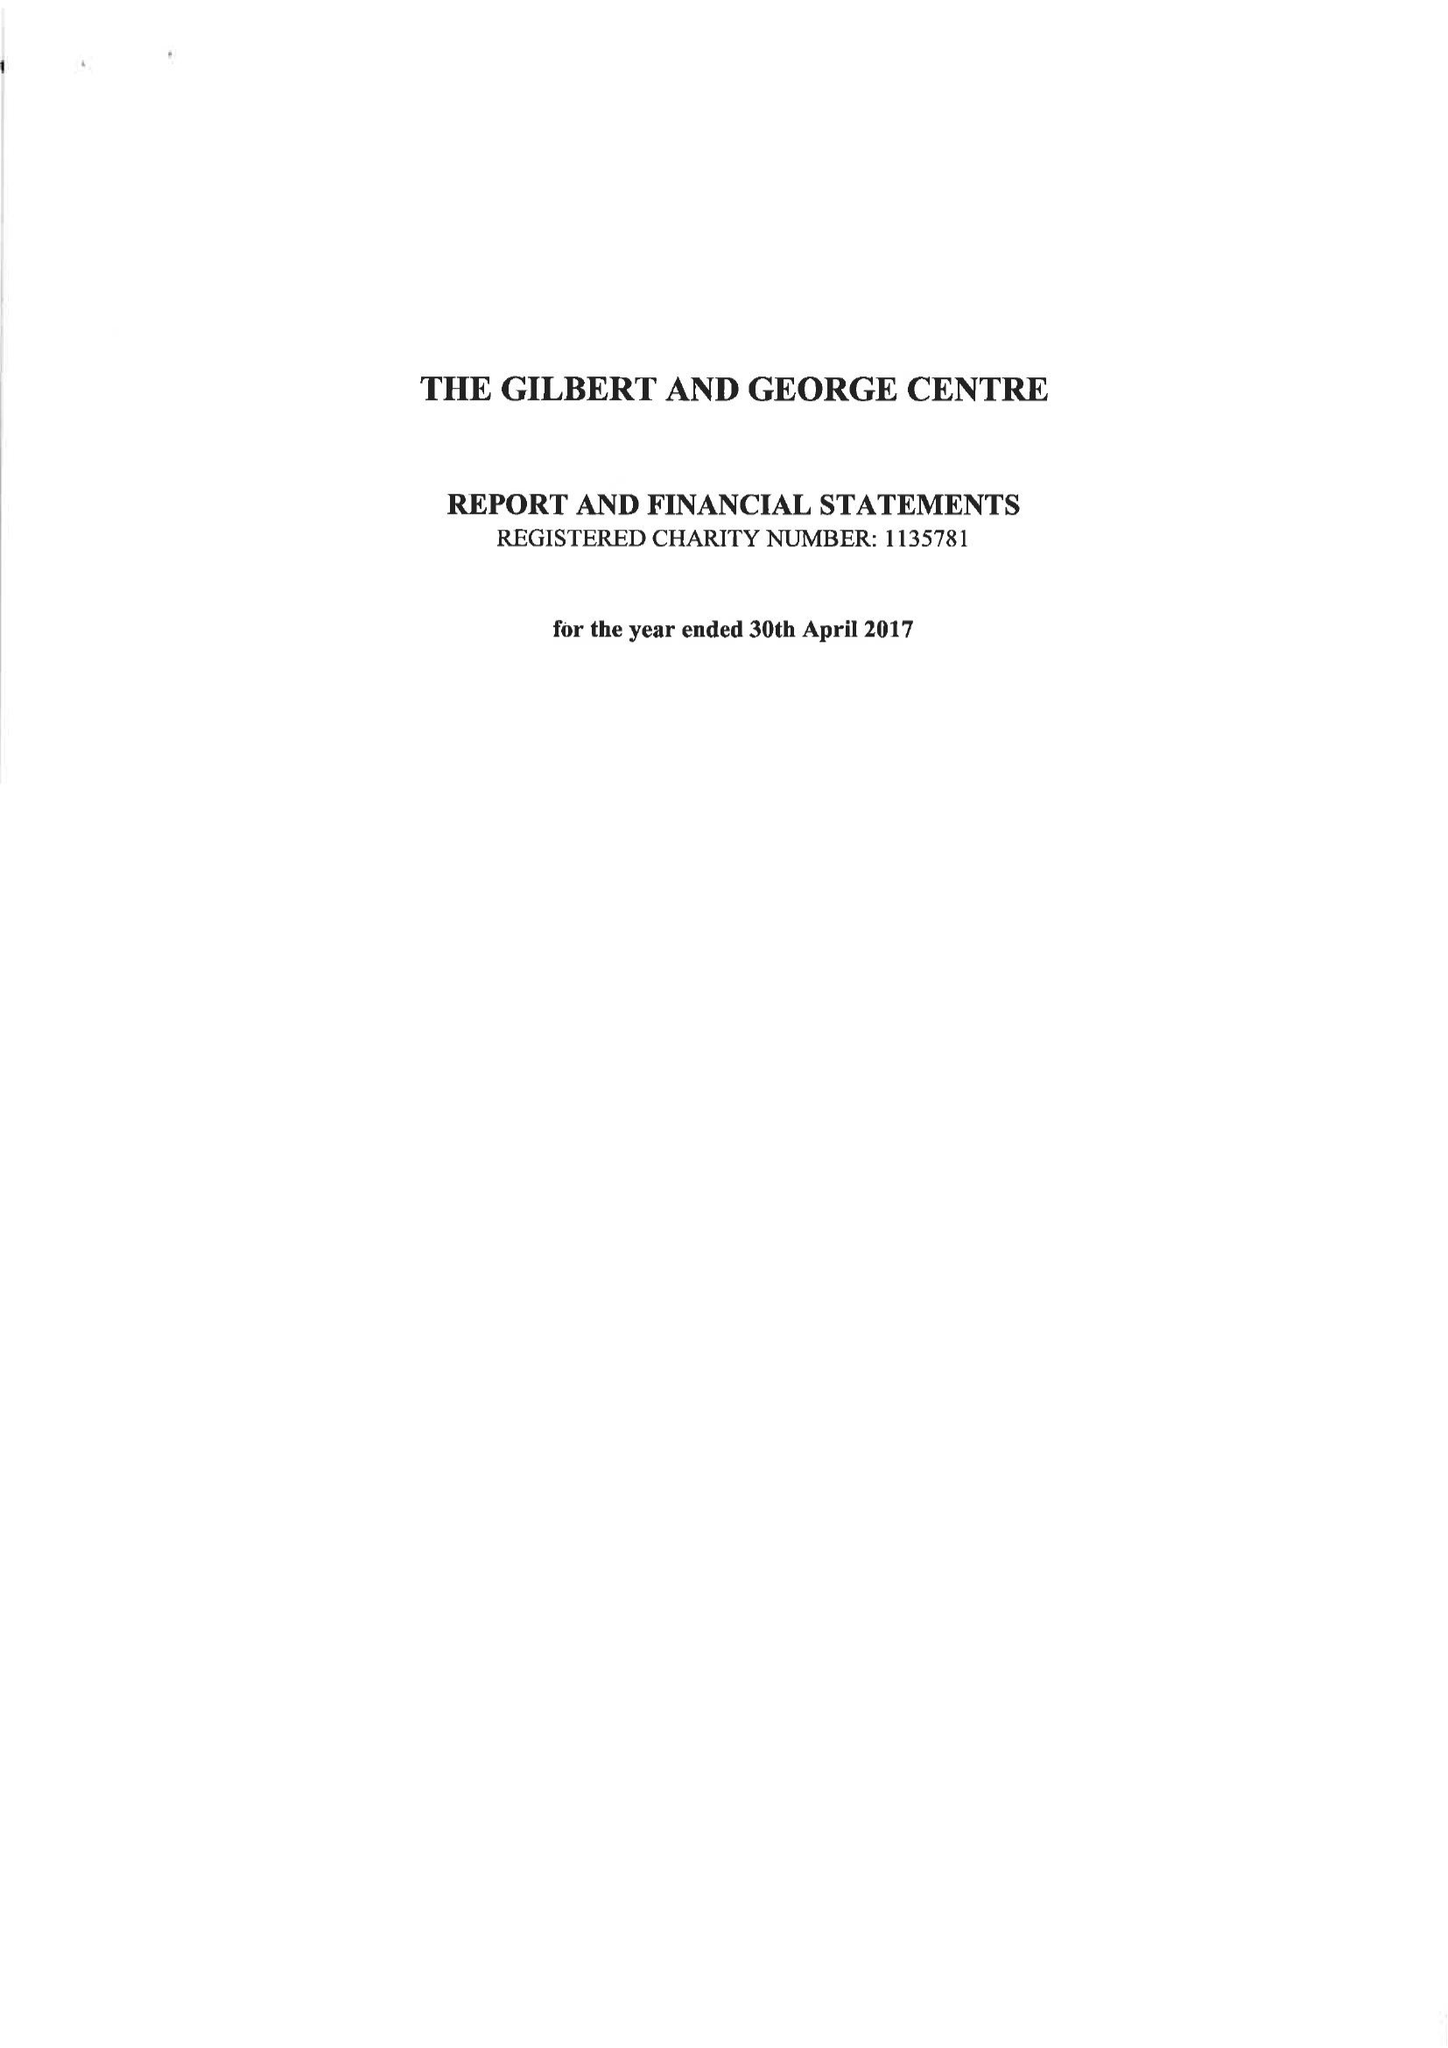What is the value for the charity_name?
Answer the question using a single word or phrase. The Gilbert and George Centre 